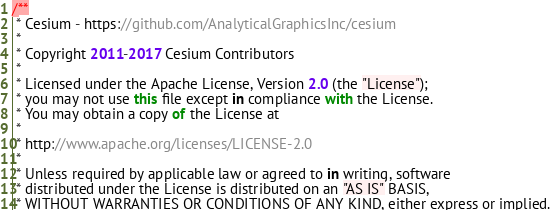Convert code to text. <code><loc_0><loc_0><loc_500><loc_500><_JavaScript_>/**
 * Cesium - https://github.com/AnalyticalGraphicsInc/cesium
 *
 * Copyright 2011-2017 Cesium Contributors
 *
 * Licensed under the Apache License, Version 2.0 (the "License");
 * you may not use this file except in compliance with the License.
 * You may obtain a copy of the License at
 *
 * http://www.apache.org/licenses/LICENSE-2.0
 *
 * Unless required by applicable law or agreed to in writing, software
 * distributed under the License is distributed on an "AS IS" BASIS,
 * WITHOUT WARRANTIES OR CONDITIONS OF ANY KIND, either express or implied.</code> 